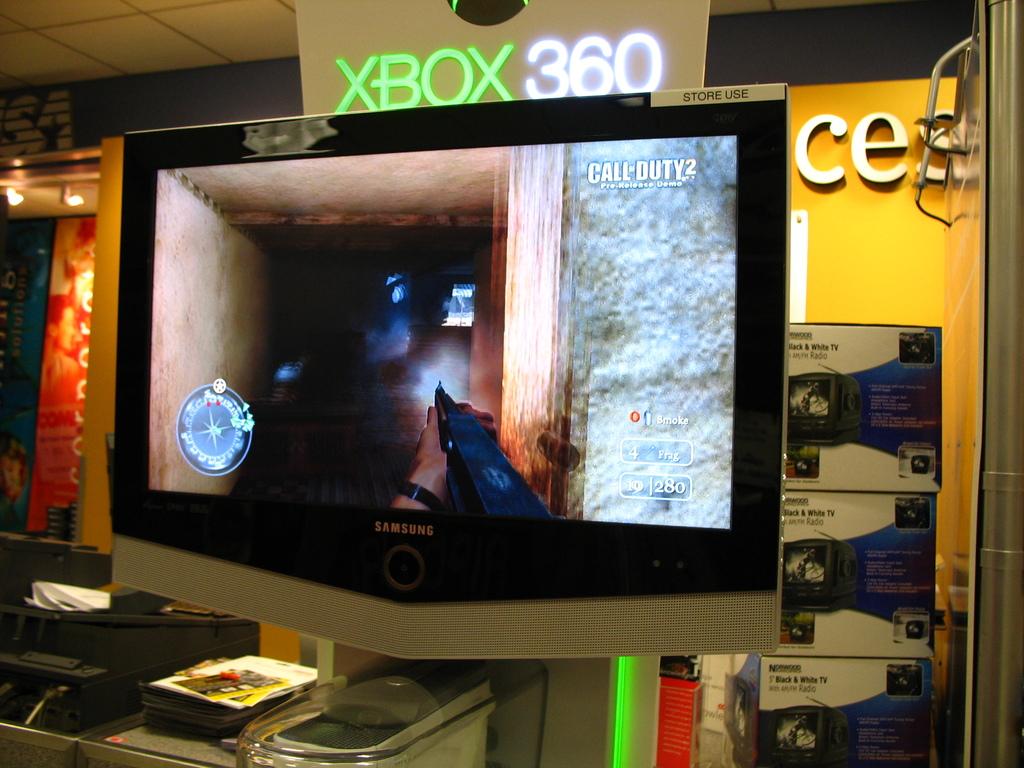What brand is the monitor?
Offer a very short reply. Samsung. What game console is advertised here?
Keep it short and to the point. Xbox 360. 